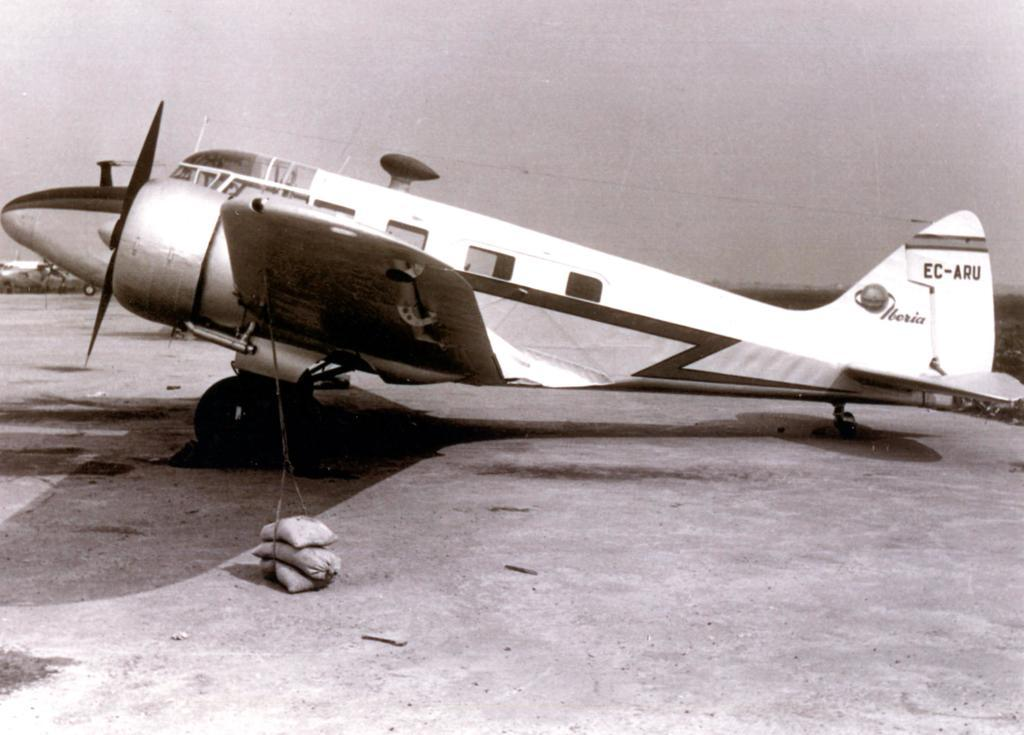What is the main subject of the image? There is an aircraft in the image. Where is the aircraft located? The aircraft is on the floor. What is the color scheme of the image? The image is in black and white. How are the sac bags arranged on the ground? The sac bags are stacked one above the other. What type of wrench is being used to repair the aircraft in the image? There is no wrench present in the image, and the aircraft is not being repaired. How fast is the aircraft running in the image? The image is a still photograph, so the aircraft is not running or moving. 